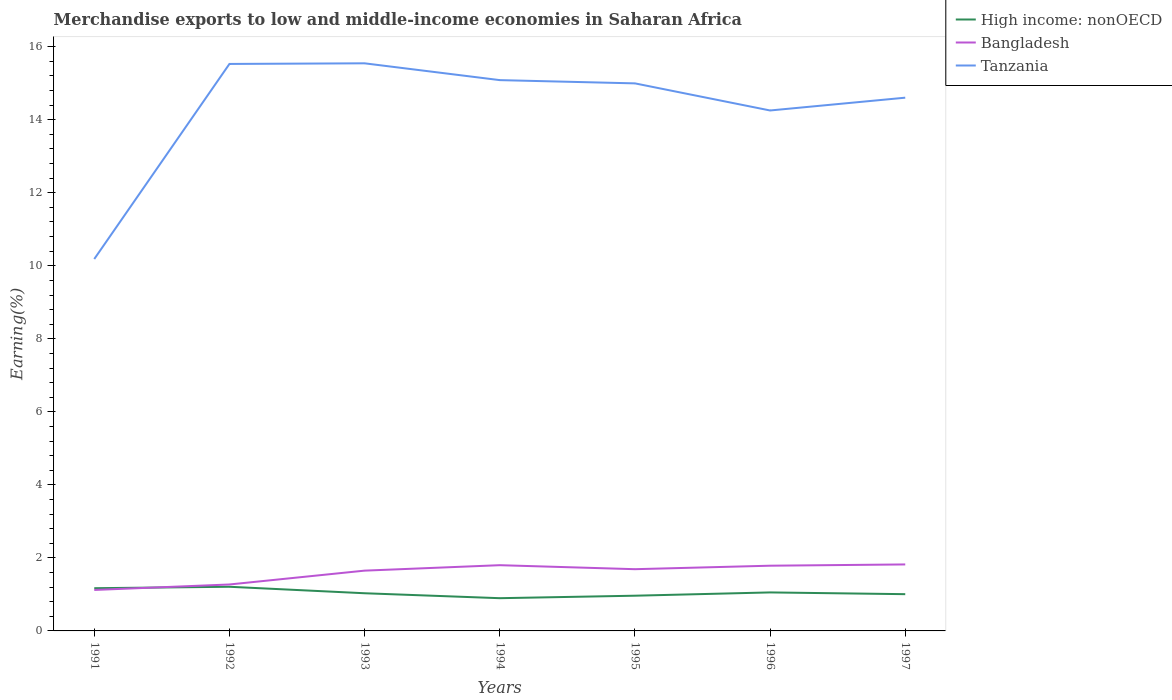Does the line corresponding to Bangladesh intersect with the line corresponding to Tanzania?
Your answer should be compact. No. Is the number of lines equal to the number of legend labels?
Provide a succinct answer. Yes. Across all years, what is the maximum percentage of amount earned from merchandise exports in Bangladesh?
Your response must be concise. 1.12. In which year was the percentage of amount earned from merchandise exports in Bangladesh maximum?
Offer a very short reply. 1991. What is the total percentage of amount earned from merchandise exports in Bangladesh in the graph?
Provide a succinct answer. -0.57. What is the difference between the highest and the second highest percentage of amount earned from merchandise exports in Tanzania?
Ensure brevity in your answer.  5.36. What is the difference between the highest and the lowest percentage of amount earned from merchandise exports in Bangladesh?
Your response must be concise. 5. What is the difference between two consecutive major ticks on the Y-axis?
Give a very brief answer. 2. Does the graph contain grids?
Give a very brief answer. No. How many legend labels are there?
Your answer should be very brief. 3. What is the title of the graph?
Your answer should be compact. Merchandise exports to low and middle-income economies in Saharan Africa. What is the label or title of the Y-axis?
Ensure brevity in your answer.  Earning(%). What is the Earning(%) of High income: nonOECD in 1991?
Your response must be concise. 1.17. What is the Earning(%) of Bangladesh in 1991?
Your answer should be compact. 1.12. What is the Earning(%) in Tanzania in 1991?
Make the answer very short. 10.19. What is the Earning(%) of High income: nonOECD in 1992?
Your answer should be compact. 1.21. What is the Earning(%) in Bangladesh in 1992?
Your answer should be compact. 1.27. What is the Earning(%) in Tanzania in 1992?
Your answer should be compact. 15.53. What is the Earning(%) in High income: nonOECD in 1993?
Make the answer very short. 1.03. What is the Earning(%) of Bangladesh in 1993?
Keep it short and to the point. 1.65. What is the Earning(%) in Tanzania in 1993?
Provide a succinct answer. 15.55. What is the Earning(%) of High income: nonOECD in 1994?
Your response must be concise. 0.9. What is the Earning(%) of Bangladesh in 1994?
Your answer should be very brief. 1.8. What is the Earning(%) in Tanzania in 1994?
Offer a terse response. 15.09. What is the Earning(%) in High income: nonOECD in 1995?
Your answer should be compact. 0.96. What is the Earning(%) of Bangladesh in 1995?
Offer a terse response. 1.69. What is the Earning(%) of Tanzania in 1995?
Your answer should be compact. 15. What is the Earning(%) of High income: nonOECD in 1996?
Make the answer very short. 1.05. What is the Earning(%) in Bangladesh in 1996?
Offer a terse response. 1.79. What is the Earning(%) in Tanzania in 1996?
Provide a short and direct response. 14.25. What is the Earning(%) of High income: nonOECD in 1997?
Your answer should be very brief. 1.01. What is the Earning(%) of Bangladesh in 1997?
Offer a terse response. 1.82. What is the Earning(%) of Tanzania in 1997?
Provide a short and direct response. 14.61. Across all years, what is the maximum Earning(%) in High income: nonOECD?
Your response must be concise. 1.21. Across all years, what is the maximum Earning(%) in Bangladesh?
Offer a very short reply. 1.82. Across all years, what is the maximum Earning(%) of Tanzania?
Ensure brevity in your answer.  15.55. Across all years, what is the minimum Earning(%) of High income: nonOECD?
Give a very brief answer. 0.9. Across all years, what is the minimum Earning(%) of Bangladesh?
Provide a succinct answer. 1.12. Across all years, what is the minimum Earning(%) in Tanzania?
Keep it short and to the point. 10.19. What is the total Earning(%) in High income: nonOECD in the graph?
Offer a terse response. 7.33. What is the total Earning(%) of Bangladesh in the graph?
Offer a terse response. 11.14. What is the total Earning(%) in Tanzania in the graph?
Provide a short and direct response. 100.2. What is the difference between the Earning(%) of High income: nonOECD in 1991 and that in 1992?
Provide a short and direct response. -0.04. What is the difference between the Earning(%) of Bangladesh in 1991 and that in 1992?
Give a very brief answer. -0.15. What is the difference between the Earning(%) in Tanzania in 1991 and that in 1992?
Make the answer very short. -5.34. What is the difference between the Earning(%) in High income: nonOECD in 1991 and that in 1993?
Your answer should be compact. 0.14. What is the difference between the Earning(%) of Bangladesh in 1991 and that in 1993?
Keep it short and to the point. -0.53. What is the difference between the Earning(%) of Tanzania in 1991 and that in 1993?
Provide a short and direct response. -5.36. What is the difference between the Earning(%) of High income: nonOECD in 1991 and that in 1994?
Make the answer very short. 0.27. What is the difference between the Earning(%) in Bangladesh in 1991 and that in 1994?
Offer a terse response. -0.68. What is the difference between the Earning(%) in Tanzania in 1991 and that in 1994?
Keep it short and to the point. -4.9. What is the difference between the Earning(%) in High income: nonOECD in 1991 and that in 1995?
Give a very brief answer. 0.21. What is the difference between the Earning(%) of Bangladesh in 1991 and that in 1995?
Your answer should be compact. -0.57. What is the difference between the Earning(%) in Tanzania in 1991 and that in 1995?
Your response must be concise. -4.81. What is the difference between the Earning(%) in High income: nonOECD in 1991 and that in 1996?
Keep it short and to the point. 0.12. What is the difference between the Earning(%) in Bangladesh in 1991 and that in 1996?
Your response must be concise. -0.66. What is the difference between the Earning(%) of Tanzania in 1991 and that in 1996?
Provide a short and direct response. -4.07. What is the difference between the Earning(%) in High income: nonOECD in 1991 and that in 1997?
Your response must be concise. 0.16. What is the difference between the Earning(%) of Bangladesh in 1991 and that in 1997?
Offer a terse response. -0.7. What is the difference between the Earning(%) of Tanzania in 1991 and that in 1997?
Offer a terse response. -4.42. What is the difference between the Earning(%) in High income: nonOECD in 1992 and that in 1993?
Offer a terse response. 0.18. What is the difference between the Earning(%) in Bangladesh in 1992 and that in 1993?
Your answer should be compact. -0.38. What is the difference between the Earning(%) of Tanzania in 1992 and that in 1993?
Give a very brief answer. -0.02. What is the difference between the Earning(%) in High income: nonOECD in 1992 and that in 1994?
Offer a terse response. 0.31. What is the difference between the Earning(%) of Bangladesh in 1992 and that in 1994?
Provide a short and direct response. -0.53. What is the difference between the Earning(%) in Tanzania in 1992 and that in 1994?
Provide a succinct answer. 0.44. What is the difference between the Earning(%) in High income: nonOECD in 1992 and that in 1995?
Keep it short and to the point. 0.24. What is the difference between the Earning(%) of Bangladesh in 1992 and that in 1995?
Offer a terse response. -0.42. What is the difference between the Earning(%) in Tanzania in 1992 and that in 1995?
Keep it short and to the point. 0.53. What is the difference between the Earning(%) of High income: nonOECD in 1992 and that in 1996?
Give a very brief answer. 0.15. What is the difference between the Earning(%) of Bangladesh in 1992 and that in 1996?
Provide a succinct answer. -0.51. What is the difference between the Earning(%) of Tanzania in 1992 and that in 1996?
Offer a terse response. 1.27. What is the difference between the Earning(%) of High income: nonOECD in 1992 and that in 1997?
Keep it short and to the point. 0.2. What is the difference between the Earning(%) in Bangladesh in 1992 and that in 1997?
Provide a succinct answer. -0.55. What is the difference between the Earning(%) in Tanzania in 1992 and that in 1997?
Provide a short and direct response. 0.92. What is the difference between the Earning(%) in High income: nonOECD in 1993 and that in 1994?
Your answer should be compact. 0.14. What is the difference between the Earning(%) in Bangladesh in 1993 and that in 1994?
Provide a short and direct response. -0.15. What is the difference between the Earning(%) in Tanzania in 1993 and that in 1994?
Offer a very short reply. 0.46. What is the difference between the Earning(%) of High income: nonOECD in 1993 and that in 1995?
Ensure brevity in your answer.  0.07. What is the difference between the Earning(%) in Bangladesh in 1993 and that in 1995?
Keep it short and to the point. -0.04. What is the difference between the Earning(%) in Tanzania in 1993 and that in 1995?
Offer a very short reply. 0.55. What is the difference between the Earning(%) of High income: nonOECD in 1993 and that in 1996?
Your answer should be very brief. -0.02. What is the difference between the Earning(%) in Bangladesh in 1993 and that in 1996?
Your answer should be very brief. -0.14. What is the difference between the Earning(%) in Tanzania in 1993 and that in 1996?
Make the answer very short. 1.29. What is the difference between the Earning(%) of High income: nonOECD in 1993 and that in 1997?
Make the answer very short. 0.03. What is the difference between the Earning(%) in Bangladesh in 1993 and that in 1997?
Provide a succinct answer. -0.17. What is the difference between the Earning(%) of Tanzania in 1993 and that in 1997?
Your answer should be very brief. 0.94. What is the difference between the Earning(%) in High income: nonOECD in 1994 and that in 1995?
Give a very brief answer. -0.07. What is the difference between the Earning(%) in Bangladesh in 1994 and that in 1995?
Offer a very short reply. 0.11. What is the difference between the Earning(%) in Tanzania in 1994 and that in 1995?
Keep it short and to the point. 0.09. What is the difference between the Earning(%) in High income: nonOECD in 1994 and that in 1996?
Provide a short and direct response. -0.16. What is the difference between the Earning(%) of Bangladesh in 1994 and that in 1996?
Make the answer very short. 0.01. What is the difference between the Earning(%) in Tanzania in 1994 and that in 1996?
Ensure brevity in your answer.  0.83. What is the difference between the Earning(%) of High income: nonOECD in 1994 and that in 1997?
Your response must be concise. -0.11. What is the difference between the Earning(%) in Bangladesh in 1994 and that in 1997?
Your answer should be very brief. -0.02. What is the difference between the Earning(%) in Tanzania in 1994 and that in 1997?
Make the answer very short. 0.48. What is the difference between the Earning(%) of High income: nonOECD in 1995 and that in 1996?
Provide a succinct answer. -0.09. What is the difference between the Earning(%) of Bangladesh in 1995 and that in 1996?
Provide a succinct answer. -0.1. What is the difference between the Earning(%) of Tanzania in 1995 and that in 1996?
Your answer should be compact. 0.74. What is the difference between the Earning(%) of High income: nonOECD in 1995 and that in 1997?
Your answer should be very brief. -0.04. What is the difference between the Earning(%) of Bangladesh in 1995 and that in 1997?
Provide a short and direct response. -0.13. What is the difference between the Earning(%) of Tanzania in 1995 and that in 1997?
Your answer should be compact. 0.39. What is the difference between the Earning(%) of High income: nonOECD in 1996 and that in 1997?
Provide a succinct answer. 0.05. What is the difference between the Earning(%) of Bangladesh in 1996 and that in 1997?
Your answer should be very brief. -0.03. What is the difference between the Earning(%) of Tanzania in 1996 and that in 1997?
Give a very brief answer. -0.35. What is the difference between the Earning(%) in High income: nonOECD in 1991 and the Earning(%) in Bangladesh in 1992?
Make the answer very short. -0.1. What is the difference between the Earning(%) of High income: nonOECD in 1991 and the Earning(%) of Tanzania in 1992?
Provide a succinct answer. -14.36. What is the difference between the Earning(%) in Bangladesh in 1991 and the Earning(%) in Tanzania in 1992?
Your response must be concise. -14.41. What is the difference between the Earning(%) in High income: nonOECD in 1991 and the Earning(%) in Bangladesh in 1993?
Make the answer very short. -0.48. What is the difference between the Earning(%) in High income: nonOECD in 1991 and the Earning(%) in Tanzania in 1993?
Your response must be concise. -14.38. What is the difference between the Earning(%) of Bangladesh in 1991 and the Earning(%) of Tanzania in 1993?
Make the answer very short. -14.42. What is the difference between the Earning(%) in High income: nonOECD in 1991 and the Earning(%) in Bangladesh in 1994?
Provide a short and direct response. -0.63. What is the difference between the Earning(%) of High income: nonOECD in 1991 and the Earning(%) of Tanzania in 1994?
Give a very brief answer. -13.92. What is the difference between the Earning(%) in Bangladesh in 1991 and the Earning(%) in Tanzania in 1994?
Ensure brevity in your answer.  -13.96. What is the difference between the Earning(%) in High income: nonOECD in 1991 and the Earning(%) in Bangladesh in 1995?
Provide a short and direct response. -0.52. What is the difference between the Earning(%) in High income: nonOECD in 1991 and the Earning(%) in Tanzania in 1995?
Give a very brief answer. -13.83. What is the difference between the Earning(%) in Bangladesh in 1991 and the Earning(%) in Tanzania in 1995?
Provide a short and direct response. -13.87. What is the difference between the Earning(%) of High income: nonOECD in 1991 and the Earning(%) of Bangladesh in 1996?
Offer a terse response. -0.62. What is the difference between the Earning(%) of High income: nonOECD in 1991 and the Earning(%) of Tanzania in 1996?
Give a very brief answer. -13.08. What is the difference between the Earning(%) in Bangladesh in 1991 and the Earning(%) in Tanzania in 1996?
Provide a short and direct response. -13.13. What is the difference between the Earning(%) of High income: nonOECD in 1991 and the Earning(%) of Bangladesh in 1997?
Your answer should be compact. -0.65. What is the difference between the Earning(%) of High income: nonOECD in 1991 and the Earning(%) of Tanzania in 1997?
Make the answer very short. -13.44. What is the difference between the Earning(%) in Bangladesh in 1991 and the Earning(%) in Tanzania in 1997?
Your answer should be very brief. -13.48. What is the difference between the Earning(%) in High income: nonOECD in 1992 and the Earning(%) in Bangladesh in 1993?
Your answer should be compact. -0.44. What is the difference between the Earning(%) in High income: nonOECD in 1992 and the Earning(%) in Tanzania in 1993?
Ensure brevity in your answer.  -14.34. What is the difference between the Earning(%) of Bangladesh in 1992 and the Earning(%) of Tanzania in 1993?
Offer a terse response. -14.27. What is the difference between the Earning(%) of High income: nonOECD in 1992 and the Earning(%) of Bangladesh in 1994?
Give a very brief answer. -0.59. What is the difference between the Earning(%) in High income: nonOECD in 1992 and the Earning(%) in Tanzania in 1994?
Provide a succinct answer. -13.88. What is the difference between the Earning(%) in Bangladesh in 1992 and the Earning(%) in Tanzania in 1994?
Offer a terse response. -13.81. What is the difference between the Earning(%) in High income: nonOECD in 1992 and the Earning(%) in Bangladesh in 1995?
Offer a terse response. -0.48. What is the difference between the Earning(%) in High income: nonOECD in 1992 and the Earning(%) in Tanzania in 1995?
Your answer should be very brief. -13.79. What is the difference between the Earning(%) of Bangladesh in 1992 and the Earning(%) of Tanzania in 1995?
Give a very brief answer. -13.72. What is the difference between the Earning(%) of High income: nonOECD in 1992 and the Earning(%) of Bangladesh in 1996?
Your answer should be compact. -0.58. What is the difference between the Earning(%) in High income: nonOECD in 1992 and the Earning(%) in Tanzania in 1996?
Provide a succinct answer. -13.05. What is the difference between the Earning(%) of Bangladesh in 1992 and the Earning(%) of Tanzania in 1996?
Give a very brief answer. -12.98. What is the difference between the Earning(%) in High income: nonOECD in 1992 and the Earning(%) in Bangladesh in 1997?
Your answer should be compact. -0.61. What is the difference between the Earning(%) of High income: nonOECD in 1992 and the Earning(%) of Tanzania in 1997?
Provide a short and direct response. -13.4. What is the difference between the Earning(%) in Bangladesh in 1992 and the Earning(%) in Tanzania in 1997?
Keep it short and to the point. -13.33. What is the difference between the Earning(%) of High income: nonOECD in 1993 and the Earning(%) of Bangladesh in 1994?
Provide a succinct answer. -0.77. What is the difference between the Earning(%) of High income: nonOECD in 1993 and the Earning(%) of Tanzania in 1994?
Offer a very short reply. -14.05. What is the difference between the Earning(%) of Bangladesh in 1993 and the Earning(%) of Tanzania in 1994?
Ensure brevity in your answer.  -13.43. What is the difference between the Earning(%) in High income: nonOECD in 1993 and the Earning(%) in Bangladesh in 1995?
Your answer should be compact. -0.66. What is the difference between the Earning(%) in High income: nonOECD in 1993 and the Earning(%) in Tanzania in 1995?
Make the answer very short. -13.96. What is the difference between the Earning(%) of Bangladesh in 1993 and the Earning(%) of Tanzania in 1995?
Provide a succinct answer. -13.35. What is the difference between the Earning(%) in High income: nonOECD in 1993 and the Earning(%) in Bangladesh in 1996?
Keep it short and to the point. -0.75. What is the difference between the Earning(%) of High income: nonOECD in 1993 and the Earning(%) of Tanzania in 1996?
Ensure brevity in your answer.  -13.22. What is the difference between the Earning(%) in Bangladesh in 1993 and the Earning(%) in Tanzania in 1996?
Give a very brief answer. -12.6. What is the difference between the Earning(%) in High income: nonOECD in 1993 and the Earning(%) in Bangladesh in 1997?
Your answer should be compact. -0.79. What is the difference between the Earning(%) of High income: nonOECD in 1993 and the Earning(%) of Tanzania in 1997?
Provide a short and direct response. -13.57. What is the difference between the Earning(%) of Bangladesh in 1993 and the Earning(%) of Tanzania in 1997?
Provide a succinct answer. -12.95. What is the difference between the Earning(%) in High income: nonOECD in 1994 and the Earning(%) in Bangladesh in 1995?
Your answer should be compact. -0.79. What is the difference between the Earning(%) in High income: nonOECD in 1994 and the Earning(%) in Tanzania in 1995?
Keep it short and to the point. -14.1. What is the difference between the Earning(%) of Bangladesh in 1994 and the Earning(%) of Tanzania in 1995?
Offer a terse response. -13.2. What is the difference between the Earning(%) in High income: nonOECD in 1994 and the Earning(%) in Bangladesh in 1996?
Make the answer very short. -0.89. What is the difference between the Earning(%) in High income: nonOECD in 1994 and the Earning(%) in Tanzania in 1996?
Keep it short and to the point. -13.36. What is the difference between the Earning(%) in Bangladesh in 1994 and the Earning(%) in Tanzania in 1996?
Offer a terse response. -12.45. What is the difference between the Earning(%) in High income: nonOECD in 1994 and the Earning(%) in Bangladesh in 1997?
Ensure brevity in your answer.  -0.92. What is the difference between the Earning(%) of High income: nonOECD in 1994 and the Earning(%) of Tanzania in 1997?
Offer a terse response. -13.71. What is the difference between the Earning(%) of Bangladesh in 1994 and the Earning(%) of Tanzania in 1997?
Keep it short and to the point. -12.8. What is the difference between the Earning(%) of High income: nonOECD in 1995 and the Earning(%) of Bangladesh in 1996?
Your answer should be compact. -0.82. What is the difference between the Earning(%) of High income: nonOECD in 1995 and the Earning(%) of Tanzania in 1996?
Provide a succinct answer. -13.29. What is the difference between the Earning(%) in Bangladesh in 1995 and the Earning(%) in Tanzania in 1996?
Keep it short and to the point. -12.56. What is the difference between the Earning(%) of High income: nonOECD in 1995 and the Earning(%) of Bangladesh in 1997?
Give a very brief answer. -0.86. What is the difference between the Earning(%) of High income: nonOECD in 1995 and the Earning(%) of Tanzania in 1997?
Your response must be concise. -13.64. What is the difference between the Earning(%) of Bangladesh in 1995 and the Earning(%) of Tanzania in 1997?
Make the answer very short. -12.91. What is the difference between the Earning(%) of High income: nonOECD in 1996 and the Earning(%) of Bangladesh in 1997?
Your response must be concise. -0.77. What is the difference between the Earning(%) in High income: nonOECD in 1996 and the Earning(%) in Tanzania in 1997?
Your answer should be compact. -13.55. What is the difference between the Earning(%) in Bangladesh in 1996 and the Earning(%) in Tanzania in 1997?
Your answer should be very brief. -12.82. What is the average Earning(%) of High income: nonOECD per year?
Provide a short and direct response. 1.05. What is the average Earning(%) of Bangladesh per year?
Your response must be concise. 1.59. What is the average Earning(%) in Tanzania per year?
Offer a very short reply. 14.31. In the year 1991, what is the difference between the Earning(%) in High income: nonOECD and Earning(%) in Bangladesh?
Provide a succinct answer. 0.05. In the year 1991, what is the difference between the Earning(%) in High income: nonOECD and Earning(%) in Tanzania?
Keep it short and to the point. -9.02. In the year 1991, what is the difference between the Earning(%) in Bangladesh and Earning(%) in Tanzania?
Make the answer very short. -9.06. In the year 1992, what is the difference between the Earning(%) of High income: nonOECD and Earning(%) of Bangladesh?
Your answer should be compact. -0.06. In the year 1992, what is the difference between the Earning(%) of High income: nonOECD and Earning(%) of Tanzania?
Your answer should be very brief. -14.32. In the year 1992, what is the difference between the Earning(%) of Bangladesh and Earning(%) of Tanzania?
Your answer should be compact. -14.26. In the year 1993, what is the difference between the Earning(%) of High income: nonOECD and Earning(%) of Bangladesh?
Ensure brevity in your answer.  -0.62. In the year 1993, what is the difference between the Earning(%) of High income: nonOECD and Earning(%) of Tanzania?
Your answer should be very brief. -14.51. In the year 1993, what is the difference between the Earning(%) in Bangladesh and Earning(%) in Tanzania?
Your answer should be very brief. -13.89. In the year 1994, what is the difference between the Earning(%) of High income: nonOECD and Earning(%) of Bangladesh?
Your answer should be very brief. -0.9. In the year 1994, what is the difference between the Earning(%) in High income: nonOECD and Earning(%) in Tanzania?
Your response must be concise. -14.19. In the year 1994, what is the difference between the Earning(%) in Bangladesh and Earning(%) in Tanzania?
Provide a succinct answer. -13.29. In the year 1995, what is the difference between the Earning(%) in High income: nonOECD and Earning(%) in Bangladesh?
Give a very brief answer. -0.73. In the year 1995, what is the difference between the Earning(%) of High income: nonOECD and Earning(%) of Tanzania?
Offer a terse response. -14.03. In the year 1995, what is the difference between the Earning(%) in Bangladesh and Earning(%) in Tanzania?
Ensure brevity in your answer.  -13.31. In the year 1996, what is the difference between the Earning(%) in High income: nonOECD and Earning(%) in Bangladesh?
Your answer should be compact. -0.73. In the year 1996, what is the difference between the Earning(%) of High income: nonOECD and Earning(%) of Tanzania?
Your answer should be very brief. -13.2. In the year 1996, what is the difference between the Earning(%) of Bangladesh and Earning(%) of Tanzania?
Your answer should be compact. -12.47. In the year 1997, what is the difference between the Earning(%) of High income: nonOECD and Earning(%) of Bangladesh?
Make the answer very short. -0.81. In the year 1997, what is the difference between the Earning(%) of High income: nonOECD and Earning(%) of Tanzania?
Your response must be concise. -13.6. In the year 1997, what is the difference between the Earning(%) in Bangladesh and Earning(%) in Tanzania?
Your response must be concise. -12.78. What is the ratio of the Earning(%) of High income: nonOECD in 1991 to that in 1992?
Make the answer very short. 0.97. What is the ratio of the Earning(%) of Bangladesh in 1991 to that in 1992?
Offer a terse response. 0.88. What is the ratio of the Earning(%) in Tanzania in 1991 to that in 1992?
Your response must be concise. 0.66. What is the ratio of the Earning(%) of High income: nonOECD in 1991 to that in 1993?
Provide a short and direct response. 1.13. What is the ratio of the Earning(%) of Bangladesh in 1991 to that in 1993?
Give a very brief answer. 0.68. What is the ratio of the Earning(%) in Tanzania in 1991 to that in 1993?
Make the answer very short. 0.66. What is the ratio of the Earning(%) in High income: nonOECD in 1991 to that in 1994?
Keep it short and to the point. 1.3. What is the ratio of the Earning(%) in Bangladesh in 1991 to that in 1994?
Offer a very short reply. 0.62. What is the ratio of the Earning(%) in Tanzania in 1991 to that in 1994?
Provide a short and direct response. 0.68. What is the ratio of the Earning(%) in High income: nonOECD in 1991 to that in 1995?
Make the answer very short. 1.21. What is the ratio of the Earning(%) in Bangladesh in 1991 to that in 1995?
Your answer should be compact. 0.66. What is the ratio of the Earning(%) in Tanzania in 1991 to that in 1995?
Give a very brief answer. 0.68. What is the ratio of the Earning(%) in High income: nonOECD in 1991 to that in 1996?
Provide a short and direct response. 1.11. What is the ratio of the Earning(%) of Bangladesh in 1991 to that in 1996?
Give a very brief answer. 0.63. What is the ratio of the Earning(%) in Tanzania in 1991 to that in 1996?
Provide a succinct answer. 0.71. What is the ratio of the Earning(%) in High income: nonOECD in 1991 to that in 1997?
Make the answer very short. 1.16. What is the ratio of the Earning(%) of Bangladesh in 1991 to that in 1997?
Keep it short and to the point. 0.62. What is the ratio of the Earning(%) of Tanzania in 1991 to that in 1997?
Provide a succinct answer. 0.7. What is the ratio of the Earning(%) in High income: nonOECD in 1992 to that in 1993?
Ensure brevity in your answer.  1.17. What is the ratio of the Earning(%) in Bangladesh in 1992 to that in 1993?
Provide a short and direct response. 0.77. What is the ratio of the Earning(%) of Tanzania in 1992 to that in 1993?
Provide a short and direct response. 1. What is the ratio of the Earning(%) of High income: nonOECD in 1992 to that in 1994?
Offer a very short reply. 1.35. What is the ratio of the Earning(%) in Bangladesh in 1992 to that in 1994?
Provide a short and direct response. 0.71. What is the ratio of the Earning(%) of Tanzania in 1992 to that in 1994?
Give a very brief answer. 1.03. What is the ratio of the Earning(%) of High income: nonOECD in 1992 to that in 1995?
Provide a short and direct response. 1.25. What is the ratio of the Earning(%) of Bangladesh in 1992 to that in 1995?
Your answer should be very brief. 0.75. What is the ratio of the Earning(%) in Tanzania in 1992 to that in 1995?
Offer a very short reply. 1.04. What is the ratio of the Earning(%) of High income: nonOECD in 1992 to that in 1996?
Provide a succinct answer. 1.15. What is the ratio of the Earning(%) in Bangladesh in 1992 to that in 1996?
Give a very brief answer. 0.71. What is the ratio of the Earning(%) in Tanzania in 1992 to that in 1996?
Give a very brief answer. 1.09. What is the ratio of the Earning(%) of High income: nonOECD in 1992 to that in 1997?
Offer a very short reply. 1.2. What is the ratio of the Earning(%) of Bangladesh in 1992 to that in 1997?
Your answer should be compact. 0.7. What is the ratio of the Earning(%) of Tanzania in 1992 to that in 1997?
Your response must be concise. 1.06. What is the ratio of the Earning(%) of High income: nonOECD in 1993 to that in 1994?
Your answer should be compact. 1.15. What is the ratio of the Earning(%) in Bangladesh in 1993 to that in 1994?
Provide a succinct answer. 0.92. What is the ratio of the Earning(%) of Tanzania in 1993 to that in 1994?
Make the answer very short. 1.03. What is the ratio of the Earning(%) of High income: nonOECD in 1993 to that in 1995?
Your answer should be compact. 1.07. What is the ratio of the Earning(%) of Bangladesh in 1993 to that in 1995?
Give a very brief answer. 0.98. What is the ratio of the Earning(%) in Tanzania in 1993 to that in 1995?
Your response must be concise. 1.04. What is the ratio of the Earning(%) of High income: nonOECD in 1993 to that in 1996?
Offer a terse response. 0.98. What is the ratio of the Earning(%) in Bangladesh in 1993 to that in 1996?
Offer a very short reply. 0.92. What is the ratio of the Earning(%) in Tanzania in 1993 to that in 1996?
Provide a succinct answer. 1.09. What is the ratio of the Earning(%) of High income: nonOECD in 1993 to that in 1997?
Ensure brevity in your answer.  1.03. What is the ratio of the Earning(%) of Bangladesh in 1993 to that in 1997?
Your response must be concise. 0.91. What is the ratio of the Earning(%) in Tanzania in 1993 to that in 1997?
Provide a succinct answer. 1.06. What is the ratio of the Earning(%) of High income: nonOECD in 1994 to that in 1995?
Your answer should be compact. 0.93. What is the ratio of the Earning(%) of Bangladesh in 1994 to that in 1995?
Keep it short and to the point. 1.06. What is the ratio of the Earning(%) of Tanzania in 1994 to that in 1995?
Ensure brevity in your answer.  1.01. What is the ratio of the Earning(%) of High income: nonOECD in 1994 to that in 1996?
Keep it short and to the point. 0.85. What is the ratio of the Earning(%) in Bangladesh in 1994 to that in 1996?
Ensure brevity in your answer.  1.01. What is the ratio of the Earning(%) of Tanzania in 1994 to that in 1996?
Give a very brief answer. 1.06. What is the ratio of the Earning(%) in High income: nonOECD in 1994 to that in 1997?
Provide a succinct answer. 0.89. What is the ratio of the Earning(%) of Bangladesh in 1994 to that in 1997?
Offer a terse response. 0.99. What is the ratio of the Earning(%) of Tanzania in 1994 to that in 1997?
Keep it short and to the point. 1.03. What is the ratio of the Earning(%) of High income: nonOECD in 1995 to that in 1996?
Your answer should be compact. 0.91. What is the ratio of the Earning(%) in Bangladesh in 1995 to that in 1996?
Make the answer very short. 0.95. What is the ratio of the Earning(%) of Tanzania in 1995 to that in 1996?
Provide a short and direct response. 1.05. What is the ratio of the Earning(%) of High income: nonOECD in 1995 to that in 1997?
Keep it short and to the point. 0.96. What is the ratio of the Earning(%) in Tanzania in 1995 to that in 1997?
Provide a succinct answer. 1.03. What is the ratio of the Earning(%) in High income: nonOECD in 1996 to that in 1997?
Provide a short and direct response. 1.05. What is the ratio of the Earning(%) in Bangladesh in 1996 to that in 1997?
Provide a succinct answer. 0.98. What is the ratio of the Earning(%) in Tanzania in 1996 to that in 1997?
Keep it short and to the point. 0.98. What is the difference between the highest and the second highest Earning(%) of High income: nonOECD?
Offer a very short reply. 0.04. What is the difference between the highest and the second highest Earning(%) of Bangladesh?
Your answer should be compact. 0.02. What is the difference between the highest and the second highest Earning(%) in Tanzania?
Provide a short and direct response. 0.02. What is the difference between the highest and the lowest Earning(%) of High income: nonOECD?
Your response must be concise. 0.31. What is the difference between the highest and the lowest Earning(%) of Bangladesh?
Provide a short and direct response. 0.7. What is the difference between the highest and the lowest Earning(%) in Tanzania?
Offer a very short reply. 5.36. 